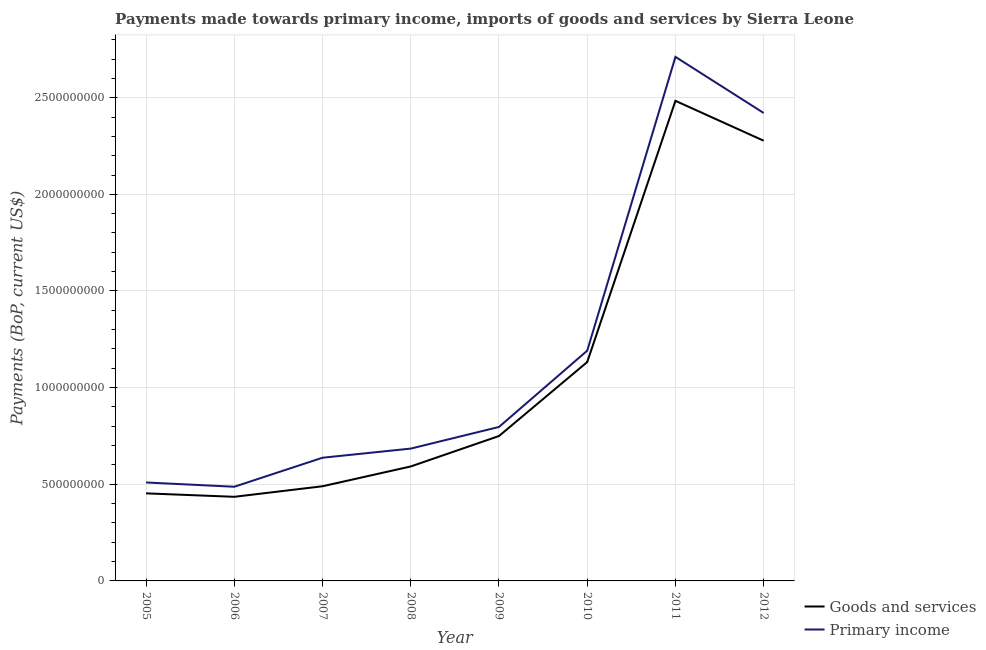What is the payments made towards goods and services in 2011?
Your answer should be very brief. 2.48e+09. Across all years, what is the maximum payments made towards primary income?
Give a very brief answer. 2.71e+09. Across all years, what is the minimum payments made towards goods and services?
Your answer should be compact. 4.35e+08. In which year was the payments made towards goods and services maximum?
Provide a short and direct response. 2011. What is the total payments made towards goods and services in the graph?
Provide a succinct answer. 8.61e+09. What is the difference between the payments made towards primary income in 2007 and that in 2012?
Provide a succinct answer. -1.78e+09. What is the difference between the payments made towards primary income in 2008 and the payments made towards goods and services in 2010?
Your answer should be compact. -4.48e+08. What is the average payments made towards goods and services per year?
Offer a terse response. 1.08e+09. In the year 2010, what is the difference between the payments made towards primary income and payments made towards goods and services?
Offer a terse response. 5.88e+07. What is the ratio of the payments made towards primary income in 2005 to that in 2008?
Offer a very short reply. 0.74. Is the difference between the payments made towards primary income in 2008 and 2012 greater than the difference between the payments made towards goods and services in 2008 and 2012?
Make the answer very short. No. What is the difference between the highest and the second highest payments made towards goods and services?
Provide a short and direct response. 2.06e+08. What is the difference between the highest and the lowest payments made towards goods and services?
Your answer should be very brief. 2.05e+09. Does the payments made towards primary income monotonically increase over the years?
Your answer should be compact. No. How many years are there in the graph?
Give a very brief answer. 8. What is the difference between two consecutive major ticks on the Y-axis?
Make the answer very short. 5.00e+08. Are the values on the major ticks of Y-axis written in scientific E-notation?
Your answer should be very brief. No. Does the graph contain any zero values?
Your answer should be very brief. No. Does the graph contain grids?
Your answer should be very brief. Yes. How many legend labels are there?
Your answer should be very brief. 2. What is the title of the graph?
Make the answer very short. Payments made towards primary income, imports of goods and services by Sierra Leone. Does "IMF nonconcessional" appear as one of the legend labels in the graph?
Offer a terse response. No. What is the label or title of the X-axis?
Ensure brevity in your answer.  Year. What is the label or title of the Y-axis?
Offer a terse response. Payments (BoP, current US$). What is the Payments (BoP, current US$) of Goods and services in 2005?
Offer a very short reply. 4.53e+08. What is the Payments (BoP, current US$) in Primary income in 2005?
Your response must be concise. 5.09e+08. What is the Payments (BoP, current US$) of Goods and services in 2006?
Provide a short and direct response. 4.35e+08. What is the Payments (BoP, current US$) of Primary income in 2006?
Offer a very short reply. 4.87e+08. What is the Payments (BoP, current US$) in Goods and services in 2007?
Keep it short and to the point. 4.90e+08. What is the Payments (BoP, current US$) in Primary income in 2007?
Offer a terse response. 6.37e+08. What is the Payments (BoP, current US$) in Goods and services in 2008?
Your answer should be very brief. 5.92e+08. What is the Payments (BoP, current US$) of Primary income in 2008?
Keep it short and to the point. 6.85e+08. What is the Payments (BoP, current US$) in Goods and services in 2009?
Offer a terse response. 7.50e+08. What is the Payments (BoP, current US$) of Primary income in 2009?
Keep it short and to the point. 7.97e+08. What is the Payments (BoP, current US$) of Goods and services in 2010?
Offer a very short reply. 1.13e+09. What is the Payments (BoP, current US$) in Primary income in 2010?
Give a very brief answer. 1.19e+09. What is the Payments (BoP, current US$) in Goods and services in 2011?
Your answer should be very brief. 2.48e+09. What is the Payments (BoP, current US$) in Primary income in 2011?
Offer a terse response. 2.71e+09. What is the Payments (BoP, current US$) in Goods and services in 2012?
Ensure brevity in your answer.  2.28e+09. What is the Payments (BoP, current US$) in Primary income in 2012?
Your answer should be compact. 2.42e+09. Across all years, what is the maximum Payments (BoP, current US$) in Goods and services?
Your response must be concise. 2.48e+09. Across all years, what is the maximum Payments (BoP, current US$) in Primary income?
Make the answer very short. 2.71e+09. Across all years, what is the minimum Payments (BoP, current US$) of Goods and services?
Your answer should be very brief. 4.35e+08. Across all years, what is the minimum Payments (BoP, current US$) in Primary income?
Make the answer very short. 4.87e+08. What is the total Payments (BoP, current US$) in Goods and services in the graph?
Offer a very short reply. 8.61e+09. What is the total Payments (BoP, current US$) in Primary income in the graph?
Keep it short and to the point. 9.44e+09. What is the difference between the Payments (BoP, current US$) in Goods and services in 2005 and that in 2006?
Provide a short and direct response. 1.79e+07. What is the difference between the Payments (BoP, current US$) of Primary income in 2005 and that in 2006?
Provide a succinct answer. 2.22e+07. What is the difference between the Payments (BoP, current US$) of Goods and services in 2005 and that in 2007?
Give a very brief answer. -3.67e+07. What is the difference between the Payments (BoP, current US$) in Primary income in 2005 and that in 2007?
Your answer should be very brief. -1.28e+08. What is the difference between the Payments (BoP, current US$) of Goods and services in 2005 and that in 2008?
Make the answer very short. -1.39e+08. What is the difference between the Payments (BoP, current US$) in Primary income in 2005 and that in 2008?
Ensure brevity in your answer.  -1.75e+08. What is the difference between the Payments (BoP, current US$) in Goods and services in 2005 and that in 2009?
Your answer should be very brief. -2.97e+08. What is the difference between the Payments (BoP, current US$) of Primary income in 2005 and that in 2009?
Offer a very short reply. -2.87e+08. What is the difference between the Payments (BoP, current US$) in Goods and services in 2005 and that in 2010?
Your answer should be compact. -6.79e+08. What is the difference between the Payments (BoP, current US$) of Primary income in 2005 and that in 2010?
Your response must be concise. -6.82e+08. What is the difference between the Payments (BoP, current US$) in Goods and services in 2005 and that in 2011?
Provide a short and direct response. -2.03e+09. What is the difference between the Payments (BoP, current US$) in Primary income in 2005 and that in 2011?
Offer a terse response. -2.20e+09. What is the difference between the Payments (BoP, current US$) in Goods and services in 2005 and that in 2012?
Your answer should be compact. -1.82e+09. What is the difference between the Payments (BoP, current US$) of Primary income in 2005 and that in 2012?
Give a very brief answer. -1.91e+09. What is the difference between the Payments (BoP, current US$) in Goods and services in 2006 and that in 2007?
Provide a short and direct response. -5.46e+07. What is the difference between the Payments (BoP, current US$) in Primary income in 2006 and that in 2007?
Ensure brevity in your answer.  -1.50e+08. What is the difference between the Payments (BoP, current US$) of Goods and services in 2006 and that in 2008?
Provide a succinct answer. -1.57e+08. What is the difference between the Payments (BoP, current US$) in Primary income in 2006 and that in 2008?
Your response must be concise. -1.97e+08. What is the difference between the Payments (BoP, current US$) in Goods and services in 2006 and that in 2009?
Ensure brevity in your answer.  -3.14e+08. What is the difference between the Payments (BoP, current US$) of Primary income in 2006 and that in 2009?
Give a very brief answer. -3.09e+08. What is the difference between the Payments (BoP, current US$) in Goods and services in 2006 and that in 2010?
Ensure brevity in your answer.  -6.97e+08. What is the difference between the Payments (BoP, current US$) of Primary income in 2006 and that in 2010?
Give a very brief answer. -7.04e+08. What is the difference between the Payments (BoP, current US$) in Goods and services in 2006 and that in 2011?
Your response must be concise. -2.05e+09. What is the difference between the Payments (BoP, current US$) in Primary income in 2006 and that in 2011?
Your answer should be very brief. -2.22e+09. What is the difference between the Payments (BoP, current US$) of Goods and services in 2006 and that in 2012?
Your response must be concise. -1.84e+09. What is the difference between the Payments (BoP, current US$) in Primary income in 2006 and that in 2012?
Your response must be concise. -1.93e+09. What is the difference between the Payments (BoP, current US$) in Goods and services in 2007 and that in 2008?
Make the answer very short. -1.02e+08. What is the difference between the Payments (BoP, current US$) of Primary income in 2007 and that in 2008?
Keep it short and to the point. -4.72e+07. What is the difference between the Payments (BoP, current US$) in Goods and services in 2007 and that in 2009?
Ensure brevity in your answer.  -2.60e+08. What is the difference between the Payments (BoP, current US$) in Primary income in 2007 and that in 2009?
Provide a short and direct response. -1.59e+08. What is the difference between the Payments (BoP, current US$) in Goods and services in 2007 and that in 2010?
Your response must be concise. -6.43e+08. What is the difference between the Payments (BoP, current US$) of Primary income in 2007 and that in 2010?
Make the answer very short. -5.54e+08. What is the difference between the Payments (BoP, current US$) of Goods and services in 2007 and that in 2011?
Your answer should be very brief. -1.99e+09. What is the difference between the Payments (BoP, current US$) in Primary income in 2007 and that in 2011?
Offer a very short reply. -2.07e+09. What is the difference between the Payments (BoP, current US$) of Goods and services in 2007 and that in 2012?
Provide a succinct answer. -1.79e+09. What is the difference between the Payments (BoP, current US$) in Primary income in 2007 and that in 2012?
Offer a terse response. -1.78e+09. What is the difference between the Payments (BoP, current US$) in Goods and services in 2008 and that in 2009?
Your answer should be very brief. -1.57e+08. What is the difference between the Payments (BoP, current US$) of Primary income in 2008 and that in 2009?
Offer a very short reply. -1.12e+08. What is the difference between the Payments (BoP, current US$) in Goods and services in 2008 and that in 2010?
Provide a succinct answer. -5.40e+08. What is the difference between the Payments (BoP, current US$) in Primary income in 2008 and that in 2010?
Ensure brevity in your answer.  -5.07e+08. What is the difference between the Payments (BoP, current US$) of Goods and services in 2008 and that in 2011?
Offer a terse response. -1.89e+09. What is the difference between the Payments (BoP, current US$) of Primary income in 2008 and that in 2011?
Your answer should be very brief. -2.03e+09. What is the difference between the Payments (BoP, current US$) of Goods and services in 2008 and that in 2012?
Provide a succinct answer. -1.69e+09. What is the difference between the Payments (BoP, current US$) in Primary income in 2008 and that in 2012?
Give a very brief answer. -1.74e+09. What is the difference between the Payments (BoP, current US$) in Goods and services in 2009 and that in 2010?
Your response must be concise. -3.83e+08. What is the difference between the Payments (BoP, current US$) in Primary income in 2009 and that in 2010?
Your answer should be very brief. -3.95e+08. What is the difference between the Payments (BoP, current US$) of Goods and services in 2009 and that in 2011?
Ensure brevity in your answer.  -1.73e+09. What is the difference between the Payments (BoP, current US$) of Primary income in 2009 and that in 2011?
Offer a very short reply. -1.91e+09. What is the difference between the Payments (BoP, current US$) of Goods and services in 2009 and that in 2012?
Your response must be concise. -1.53e+09. What is the difference between the Payments (BoP, current US$) in Primary income in 2009 and that in 2012?
Give a very brief answer. -1.62e+09. What is the difference between the Payments (BoP, current US$) in Goods and services in 2010 and that in 2011?
Provide a short and direct response. -1.35e+09. What is the difference between the Payments (BoP, current US$) in Primary income in 2010 and that in 2011?
Make the answer very short. -1.52e+09. What is the difference between the Payments (BoP, current US$) in Goods and services in 2010 and that in 2012?
Offer a terse response. -1.15e+09. What is the difference between the Payments (BoP, current US$) of Primary income in 2010 and that in 2012?
Give a very brief answer. -1.23e+09. What is the difference between the Payments (BoP, current US$) in Goods and services in 2011 and that in 2012?
Your answer should be very brief. 2.06e+08. What is the difference between the Payments (BoP, current US$) in Primary income in 2011 and that in 2012?
Offer a very short reply. 2.90e+08. What is the difference between the Payments (BoP, current US$) of Goods and services in 2005 and the Payments (BoP, current US$) of Primary income in 2006?
Your response must be concise. -3.41e+07. What is the difference between the Payments (BoP, current US$) of Goods and services in 2005 and the Payments (BoP, current US$) of Primary income in 2007?
Ensure brevity in your answer.  -1.84e+08. What is the difference between the Payments (BoP, current US$) of Goods and services in 2005 and the Payments (BoP, current US$) of Primary income in 2008?
Provide a succinct answer. -2.32e+08. What is the difference between the Payments (BoP, current US$) of Goods and services in 2005 and the Payments (BoP, current US$) of Primary income in 2009?
Your response must be concise. -3.44e+08. What is the difference between the Payments (BoP, current US$) in Goods and services in 2005 and the Payments (BoP, current US$) in Primary income in 2010?
Provide a short and direct response. -7.38e+08. What is the difference between the Payments (BoP, current US$) in Goods and services in 2005 and the Payments (BoP, current US$) in Primary income in 2011?
Your response must be concise. -2.26e+09. What is the difference between the Payments (BoP, current US$) of Goods and services in 2005 and the Payments (BoP, current US$) of Primary income in 2012?
Keep it short and to the point. -1.97e+09. What is the difference between the Payments (BoP, current US$) of Goods and services in 2006 and the Payments (BoP, current US$) of Primary income in 2007?
Keep it short and to the point. -2.02e+08. What is the difference between the Payments (BoP, current US$) of Goods and services in 2006 and the Payments (BoP, current US$) of Primary income in 2008?
Ensure brevity in your answer.  -2.49e+08. What is the difference between the Payments (BoP, current US$) of Goods and services in 2006 and the Payments (BoP, current US$) of Primary income in 2009?
Make the answer very short. -3.61e+08. What is the difference between the Payments (BoP, current US$) of Goods and services in 2006 and the Payments (BoP, current US$) of Primary income in 2010?
Your response must be concise. -7.56e+08. What is the difference between the Payments (BoP, current US$) in Goods and services in 2006 and the Payments (BoP, current US$) in Primary income in 2011?
Your answer should be very brief. -2.28e+09. What is the difference between the Payments (BoP, current US$) in Goods and services in 2006 and the Payments (BoP, current US$) in Primary income in 2012?
Give a very brief answer. -1.99e+09. What is the difference between the Payments (BoP, current US$) in Goods and services in 2007 and the Payments (BoP, current US$) in Primary income in 2008?
Your response must be concise. -1.95e+08. What is the difference between the Payments (BoP, current US$) in Goods and services in 2007 and the Payments (BoP, current US$) in Primary income in 2009?
Your answer should be very brief. -3.07e+08. What is the difference between the Payments (BoP, current US$) in Goods and services in 2007 and the Payments (BoP, current US$) in Primary income in 2010?
Your answer should be very brief. -7.01e+08. What is the difference between the Payments (BoP, current US$) in Goods and services in 2007 and the Payments (BoP, current US$) in Primary income in 2011?
Provide a short and direct response. -2.22e+09. What is the difference between the Payments (BoP, current US$) of Goods and services in 2007 and the Payments (BoP, current US$) of Primary income in 2012?
Give a very brief answer. -1.93e+09. What is the difference between the Payments (BoP, current US$) of Goods and services in 2008 and the Payments (BoP, current US$) of Primary income in 2009?
Offer a very short reply. -2.04e+08. What is the difference between the Payments (BoP, current US$) of Goods and services in 2008 and the Payments (BoP, current US$) of Primary income in 2010?
Keep it short and to the point. -5.99e+08. What is the difference between the Payments (BoP, current US$) in Goods and services in 2008 and the Payments (BoP, current US$) in Primary income in 2011?
Ensure brevity in your answer.  -2.12e+09. What is the difference between the Payments (BoP, current US$) in Goods and services in 2008 and the Payments (BoP, current US$) in Primary income in 2012?
Your response must be concise. -1.83e+09. What is the difference between the Payments (BoP, current US$) of Goods and services in 2009 and the Payments (BoP, current US$) of Primary income in 2010?
Provide a short and direct response. -4.42e+08. What is the difference between the Payments (BoP, current US$) in Goods and services in 2009 and the Payments (BoP, current US$) in Primary income in 2011?
Your answer should be very brief. -1.96e+09. What is the difference between the Payments (BoP, current US$) in Goods and services in 2009 and the Payments (BoP, current US$) in Primary income in 2012?
Offer a terse response. -1.67e+09. What is the difference between the Payments (BoP, current US$) in Goods and services in 2010 and the Payments (BoP, current US$) in Primary income in 2011?
Give a very brief answer. -1.58e+09. What is the difference between the Payments (BoP, current US$) in Goods and services in 2010 and the Payments (BoP, current US$) in Primary income in 2012?
Provide a short and direct response. -1.29e+09. What is the difference between the Payments (BoP, current US$) in Goods and services in 2011 and the Payments (BoP, current US$) in Primary income in 2012?
Provide a short and direct response. 6.29e+07. What is the average Payments (BoP, current US$) of Goods and services per year?
Your answer should be very brief. 1.08e+09. What is the average Payments (BoP, current US$) of Primary income per year?
Provide a short and direct response. 1.18e+09. In the year 2005, what is the difference between the Payments (BoP, current US$) in Goods and services and Payments (BoP, current US$) in Primary income?
Keep it short and to the point. -5.63e+07. In the year 2006, what is the difference between the Payments (BoP, current US$) of Goods and services and Payments (BoP, current US$) of Primary income?
Your answer should be compact. -5.20e+07. In the year 2007, what is the difference between the Payments (BoP, current US$) in Goods and services and Payments (BoP, current US$) in Primary income?
Make the answer very short. -1.48e+08. In the year 2008, what is the difference between the Payments (BoP, current US$) in Goods and services and Payments (BoP, current US$) in Primary income?
Your response must be concise. -9.24e+07. In the year 2009, what is the difference between the Payments (BoP, current US$) in Goods and services and Payments (BoP, current US$) in Primary income?
Give a very brief answer. -4.69e+07. In the year 2010, what is the difference between the Payments (BoP, current US$) in Goods and services and Payments (BoP, current US$) in Primary income?
Provide a short and direct response. -5.88e+07. In the year 2011, what is the difference between the Payments (BoP, current US$) in Goods and services and Payments (BoP, current US$) in Primary income?
Provide a succinct answer. -2.27e+08. In the year 2012, what is the difference between the Payments (BoP, current US$) of Goods and services and Payments (BoP, current US$) of Primary income?
Provide a succinct answer. -1.43e+08. What is the ratio of the Payments (BoP, current US$) of Goods and services in 2005 to that in 2006?
Your answer should be compact. 1.04. What is the ratio of the Payments (BoP, current US$) in Primary income in 2005 to that in 2006?
Make the answer very short. 1.05. What is the ratio of the Payments (BoP, current US$) of Goods and services in 2005 to that in 2007?
Keep it short and to the point. 0.93. What is the ratio of the Payments (BoP, current US$) in Primary income in 2005 to that in 2007?
Ensure brevity in your answer.  0.8. What is the ratio of the Payments (BoP, current US$) in Goods and services in 2005 to that in 2008?
Offer a terse response. 0.77. What is the ratio of the Payments (BoP, current US$) of Primary income in 2005 to that in 2008?
Offer a very short reply. 0.74. What is the ratio of the Payments (BoP, current US$) in Goods and services in 2005 to that in 2009?
Keep it short and to the point. 0.6. What is the ratio of the Payments (BoP, current US$) in Primary income in 2005 to that in 2009?
Offer a terse response. 0.64. What is the ratio of the Payments (BoP, current US$) in Goods and services in 2005 to that in 2010?
Offer a terse response. 0.4. What is the ratio of the Payments (BoP, current US$) in Primary income in 2005 to that in 2010?
Offer a terse response. 0.43. What is the ratio of the Payments (BoP, current US$) in Goods and services in 2005 to that in 2011?
Your answer should be very brief. 0.18. What is the ratio of the Payments (BoP, current US$) of Primary income in 2005 to that in 2011?
Make the answer very short. 0.19. What is the ratio of the Payments (BoP, current US$) in Goods and services in 2005 to that in 2012?
Keep it short and to the point. 0.2. What is the ratio of the Payments (BoP, current US$) in Primary income in 2005 to that in 2012?
Your answer should be very brief. 0.21. What is the ratio of the Payments (BoP, current US$) of Goods and services in 2006 to that in 2007?
Your response must be concise. 0.89. What is the ratio of the Payments (BoP, current US$) in Primary income in 2006 to that in 2007?
Your answer should be very brief. 0.76. What is the ratio of the Payments (BoP, current US$) of Goods and services in 2006 to that in 2008?
Your answer should be compact. 0.73. What is the ratio of the Payments (BoP, current US$) of Primary income in 2006 to that in 2008?
Give a very brief answer. 0.71. What is the ratio of the Payments (BoP, current US$) of Goods and services in 2006 to that in 2009?
Make the answer very short. 0.58. What is the ratio of the Payments (BoP, current US$) of Primary income in 2006 to that in 2009?
Keep it short and to the point. 0.61. What is the ratio of the Payments (BoP, current US$) in Goods and services in 2006 to that in 2010?
Offer a terse response. 0.38. What is the ratio of the Payments (BoP, current US$) of Primary income in 2006 to that in 2010?
Your answer should be compact. 0.41. What is the ratio of the Payments (BoP, current US$) in Goods and services in 2006 to that in 2011?
Give a very brief answer. 0.18. What is the ratio of the Payments (BoP, current US$) of Primary income in 2006 to that in 2011?
Provide a succinct answer. 0.18. What is the ratio of the Payments (BoP, current US$) of Goods and services in 2006 to that in 2012?
Offer a terse response. 0.19. What is the ratio of the Payments (BoP, current US$) of Primary income in 2006 to that in 2012?
Ensure brevity in your answer.  0.2. What is the ratio of the Payments (BoP, current US$) in Goods and services in 2007 to that in 2008?
Keep it short and to the point. 0.83. What is the ratio of the Payments (BoP, current US$) of Goods and services in 2007 to that in 2009?
Keep it short and to the point. 0.65. What is the ratio of the Payments (BoP, current US$) of Primary income in 2007 to that in 2009?
Ensure brevity in your answer.  0.8. What is the ratio of the Payments (BoP, current US$) in Goods and services in 2007 to that in 2010?
Provide a short and direct response. 0.43. What is the ratio of the Payments (BoP, current US$) of Primary income in 2007 to that in 2010?
Keep it short and to the point. 0.54. What is the ratio of the Payments (BoP, current US$) of Goods and services in 2007 to that in 2011?
Make the answer very short. 0.2. What is the ratio of the Payments (BoP, current US$) in Primary income in 2007 to that in 2011?
Your answer should be very brief. 0.24. What is the ratio of the Payments (BoP, current US$) in Goods and services in 2007 to that in 2012?
Offer a terse response. 0.21. What is the ratio of the Payments (BoP, current US$) of Primary income in 2007 to that in 2012?
Ensure brevity in your answer.  0.26. What is the ratio of the Payments (BoP, current US$) of Goods and services in 2008 to that in 2009?
Offer a terse response. 0.79. What is the ratio of the Payments (BoP, current US$) in Primary income in 2008 to that in 2009?
Offer a very short reply. 0.86. What is the ratio of the Payments (BoP, current US$) of Goods and services in 2008 to that in 2010?
Give a very brief answer. 0.52. What is the ratio of the Payments (BoP, current US$) in Primary income in 2008 to that in 2010?
Your answer should be compact. 0.57. What is the ratio of the Payments (BoP, current US$) in Goods and services in 2008 to that in 2011?
Your answer should be compact. 0.24. What is the ratio of the Payments (BoP, current US$) of Primary income in 2008 to that in 2011?
Offer a very short reply. 0.25. What is the ratio of the Payments (BoP, current US$) of Goods and services in 2008 to that in 2012?
Your answer should be very brief. 0.26. What is the ratio of the Payments (BoP, current US$) of Primary income in 2008 to that in 2012?
Provide a short and direct response. 0.28. What is the ratio of the Payments (BoP, current US$) of Goods and services in 2009 to that in 2010?
Ensure brevity in your answer.  0.66. What is the ratio of the Payments (BoP, current US$) of Primary income in 2009 to that in 2010?
Make the answer very short. 0.67. What is the ratio of the Payments (BoP, current US$) of Goods and services in 2009 to that in 2011?
Offer a terse response. 0.3. What is the ratio of the Payments (BoP, current US$) of Primary income in 2009 to that in 2011?
Provide a short and direct response. 0.29. What is the ratio of the Payments (BoP, current US$) in Goods and services in 2009 to that in 2012?
Ensure brevity in your answer.  0.33. What is the ratio of the Payments (BoP, current US$) in Primary income in 2009 to that in 2012?
Your response must be concise. 0.33. What is the ratio of the Payments (BoP, current US$) in Goods and services in 2010 to that in 2011?
Keep it short and to the point. 0.46. What is the ratio of the Payments (BoP, current US$) of Primary income in 2010 to that in 2011?
Provide a succinct answer. 0.44. What is the ratio of the Payments (BoP, current US$) in Goods and services in 2010 to that in 2012?
Provide a succinct answer. 0.5. What is the ratio of the Payments (BoP, current US$) in Primary income in 2010 to that in 2012?
Your answer should be compact. 0.49. What is the ratio of the Payments (BoP, current US$) of Goods and services in 2011 to that in 2012?
Make the answer very short. 1.09. What is the ratio of the Payments (BoP, current US$) of Primary income in 2011 to that in 2012?
Provide a succinct answer. 1.12. What is the difference between the highest and the second highest Payments (BoP, current US$) of Goods and services?
Keep it short and to the point. 2.06e+08. What is the difference between the highest and the second highest Payments (BoP, current US$) of Primary income?
Your answer should be compact. 2.90e+08. What is the difference between the highest and the lowest Payments (BoP, current US$) of Goods and services?
Keep it short and to the point. 2.05e+09. What is the difference between the highest and the lowest Payments (BoP, current US$) of Primary income?
Offer a terse response. 2.22e+09. 